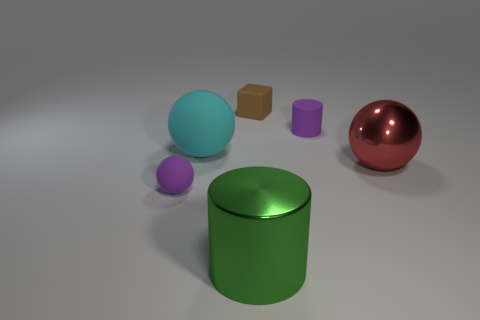Is there any other thing that has the same material as the small ball? Yes, the large shiny ball seems to be made of a similar glossy material as the small ball, reflecting light in a comparable manner. 